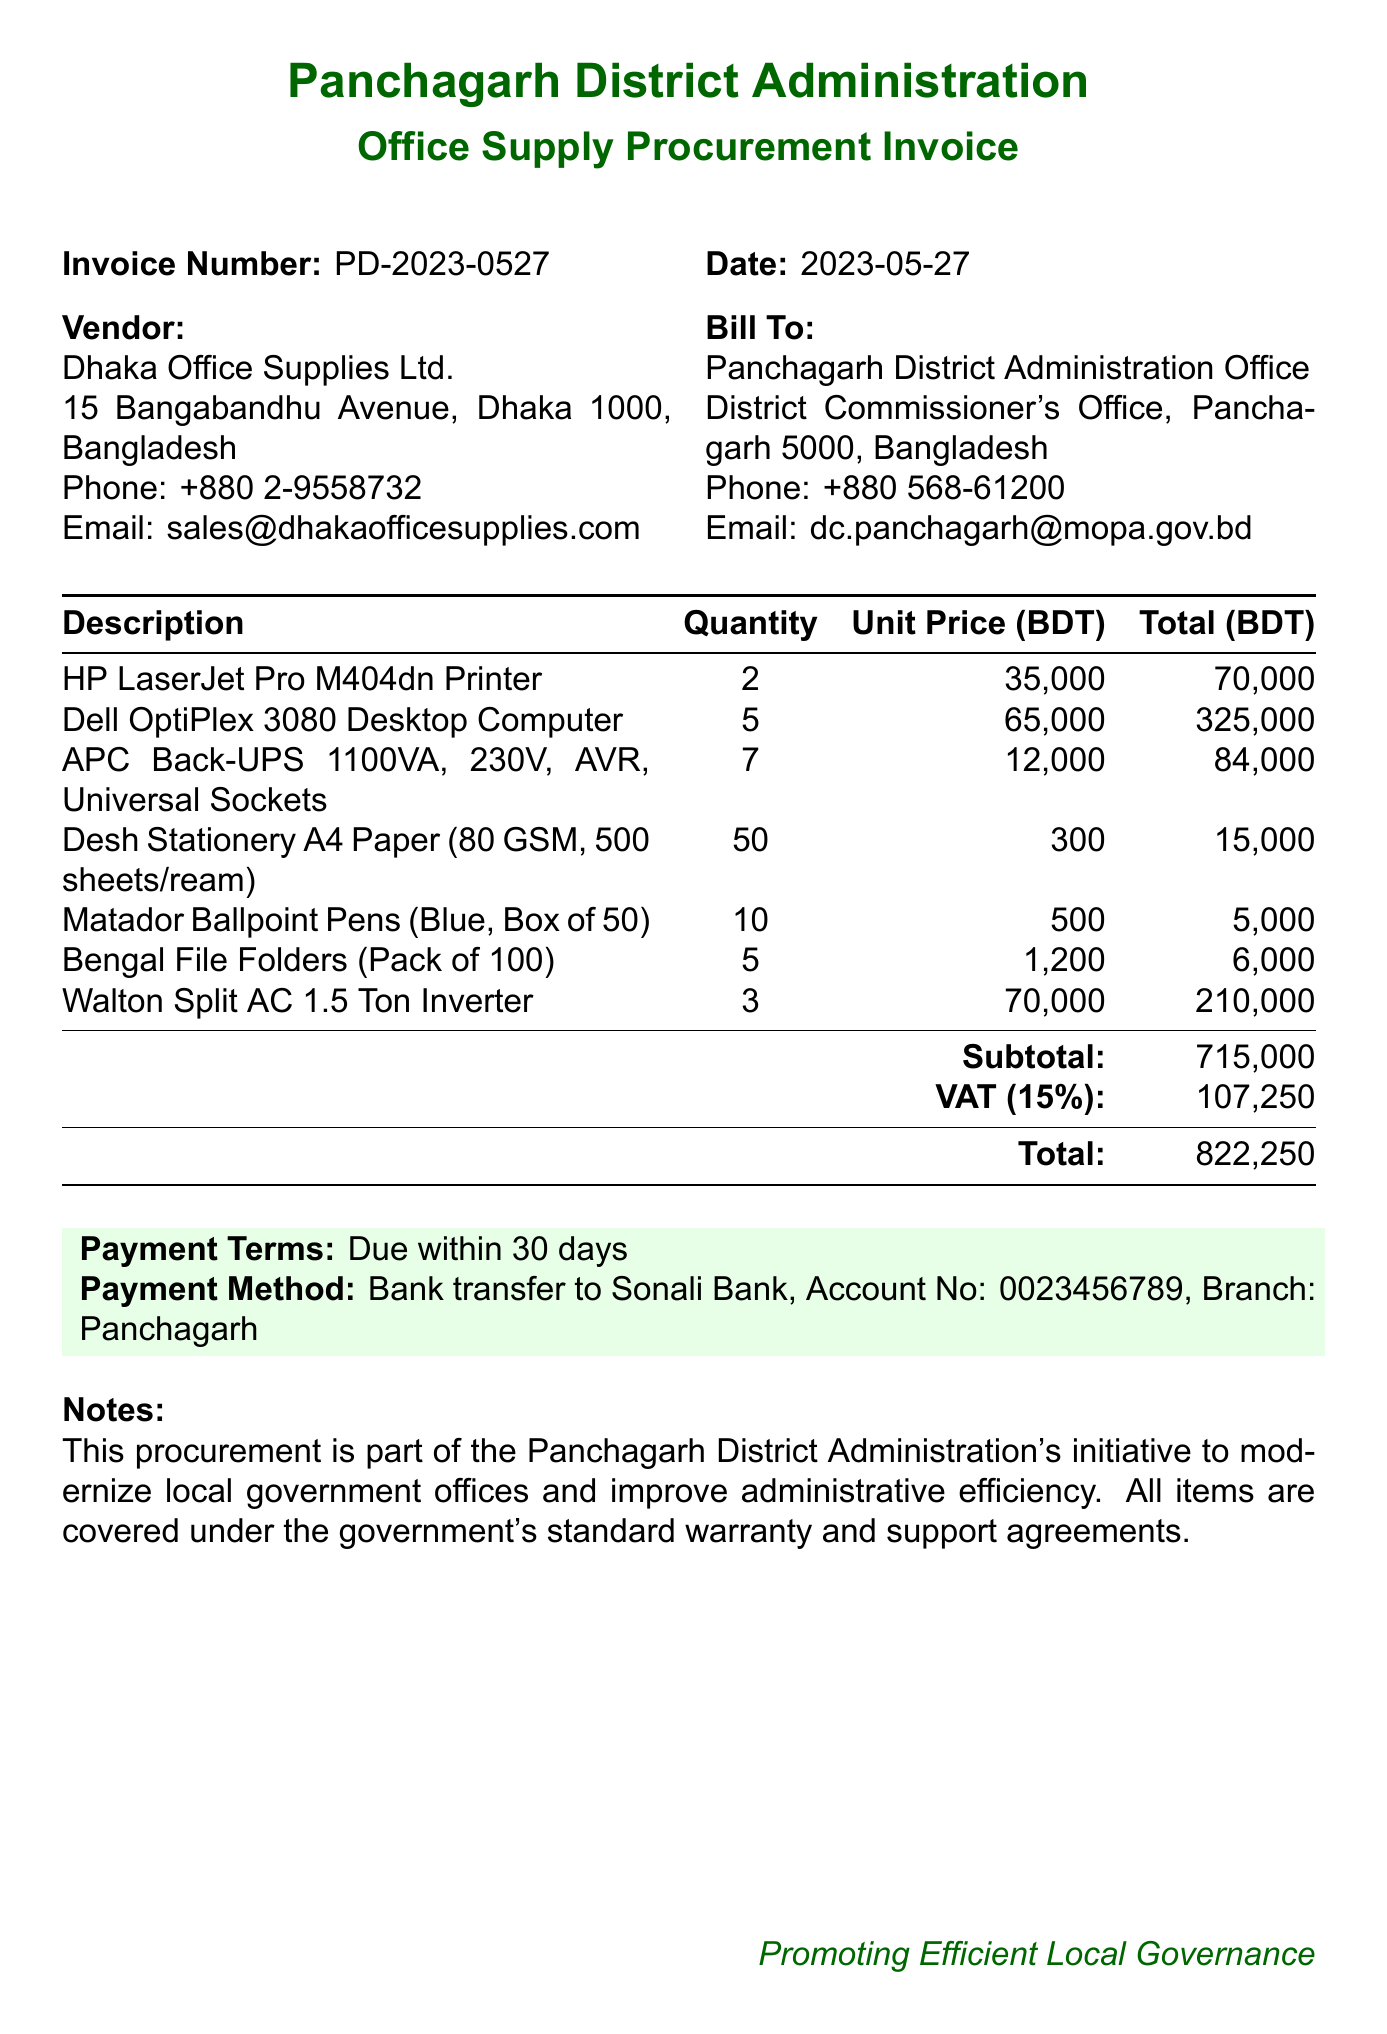What is the invoice number? The invoice number is specified in the document under the heading 'Invoice Number'.
Answer: PD-2023-0527 What is the total amount due? The total amount due is shown at the bottom of the invoice after the subtotal and VAT calculations.
Answer: 822250 Who is the vendor? The document specifies the vendor's name in the 'Vendor' section.
Answer: Dhaka Office Supplies Ltd What is the payment method? The payment method is listed in the 'Payment Method' section of the invoice.
Answer: Bank transfer to Sonali Bank How many HP LaserJet Pro M404dn Printers were purchased? The quantity of printers purchased is noted under the items list.
Answer: 2 What is the subtotal amount? The subtotal is calculated before adding VAT and is shown in the invoice.
Answer: 715000 What is the date of the invoice? The date is specified at the top of the invoice.
Answer: 2023-05-27 What items are included in this procurement? The items list includes descriptions of all items purchased, detailing office supplies and equipment.
Answer: Listed in the items section What are the payment terms? The payment terms are specified in the invoice to clarify when payment is due.
Answer: Due within 30 days 